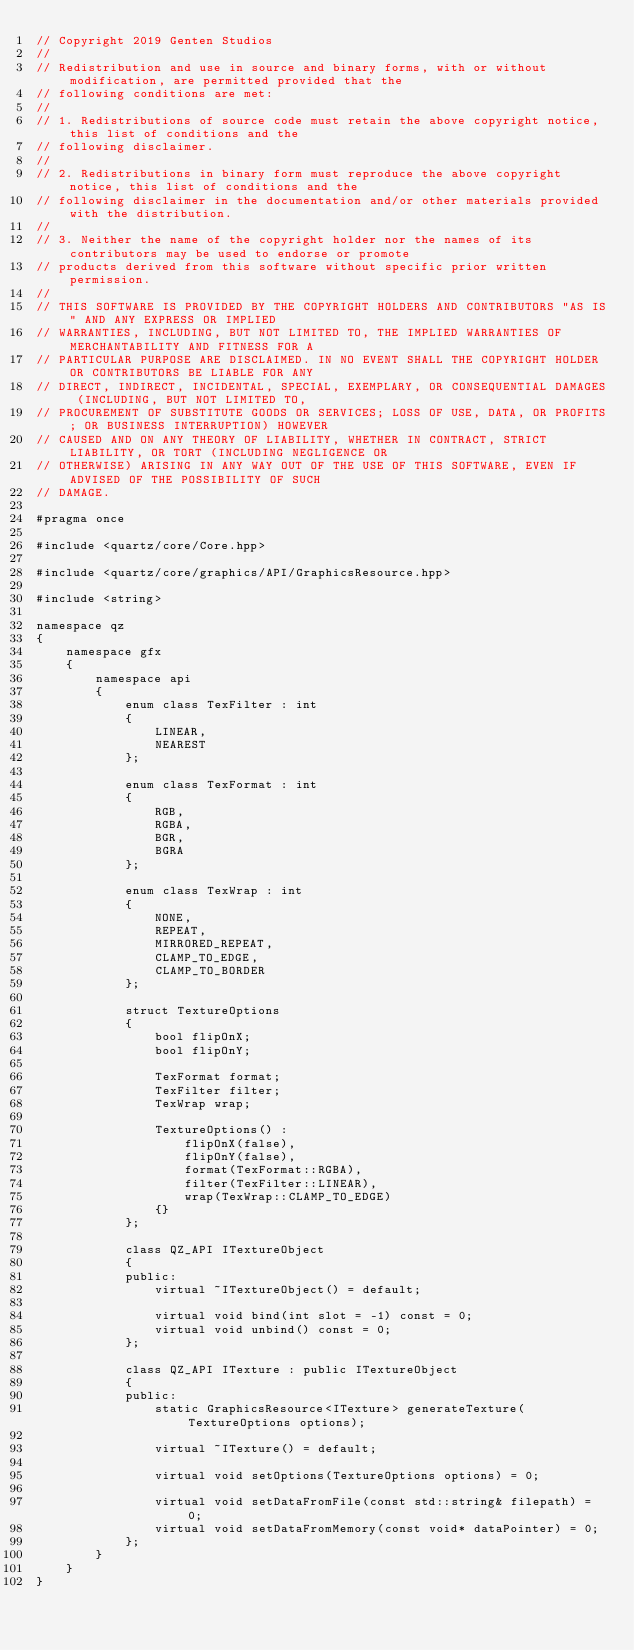<code> <loc_0><loc_0><loc_500><loc_500><_C++_>// Copyright 2019 Genten Studios
// 
// Redistribution and use in source and binary forms, with or without modification, are permitted provided that the 
// following conditions are met:
// 
// 1. Redistributions of source code must retain the above copyright notice, this list of conditions and the 
// following disclaimer.
// 
// 2. Redistributions in binary form must reproduce the above copyright notice, this list of conditions and the 
// following disclaimer in the documentation and/or other materials provided with the distribution.
// 
// 3. Neither the name of the copyright holder nor the names of its contributors may be used to endorse or promote 
// products derived from this software without specific prior written permission.
// 
// THIS SOFTWARE IS PROVIDED BY THE COPYRIGHT HOLDERS AND CONTRIBUTORS "AS IS" AND ANY EXPRESS OR IMPLIED 
// WARRANTIES, INCLUDING, BUT NOT LIMITED TO, THE IMPLIED WARRANTIES OF MERCHANTABILITY AND FITNESS FOR A 
// PARTICULAR PURPOSE ARE DISCLAIMED. IN NO EVENT SHALL THE COPYRIGHT HOLDER OR CONTRIBUTORS BE LIABLE FOR ANY 
// DIRECT, INDIRECT, INCIDENTAL, SPECIAL, EXEMPLARY, OR CONSEQUENTIAL DAMAGES (INCLUDING, BUT NOT LIMITED TO, 
// PROCUREMENT OF SUBSTITUTE GOODS OR SERVICES; LOSS OF USE, DATA, OR PROFITS; OR BUSINESS INTERRUPTION) HOWEVER 
// CAUSED AND ON ANY THEORY OF LIABILITY, WHETHER IN CONTRACT, STRICT LIABILITY, OR TORT (INCLUDING NEGLIGENCE OR 
// OTHERWISE) ARISING IN ANY WAY OUT OF THE USE OF THIS SOFTWARE, EVEN IF ADVISED OF THE POSSIBILITY OF SUCH 
// DAMAGE.

#pragma once

#include <quartz/core/Core.hpp>

#include <quartz/core/graphics/API/GraphicsResource.hpp>

#include <string>

namespace qz
{
	namespace gfx
	{
		namespace api
		{
			enum class TexFilter : int
			{
				LINEAR,
				NEAREST
			};

			enum class TexFormat : int
			{
				RGB,
				RGBA,
				BGR,
				BGRA
			};

			enum class TexWrap : int
			{
				NONE,
				REPEAT,
				MIRRORED_REPEAT,
				CLAMP_TO_EDGE,
				CLAMP_TO_BORDER
			};

			struct TextureOptions
			{
				bool flipOnX;
				bool flipOnY;

				TexFormat format;
				TexFilter filter;
				TexWrap wrap;

				TextureOptions() :
					flipOnX(false),
					flipOnY(false),
					format(TexFormat::RGBA),
					filter(TexFilter::LINEAR),
					wrap(TexWrap::CLAMP_TO_EDGE)
				{}
			};

			class QZ_API ITextureObject
			{
			public:
				virtual ~ITextureObject() = default;

				virtual void bind(int slot = -1) const = 0;
				virtual void unbind() const = 0;
			};

			class QZ_API ITexture : public ITextureObject
			{
			public:
				static GraphicsResource<ITexture> generateTexture(TextureOptions options);

				virtual ~ITexture() = default;

				virtual void setOptions(TextureOptions options) = 0;

				virtual void setDataFromFile(const std::string& filepath) = 0;
				virtual void setDataFromMemory(const void* dataPointer) = 0;
			};
		}
	}
}

</code> 